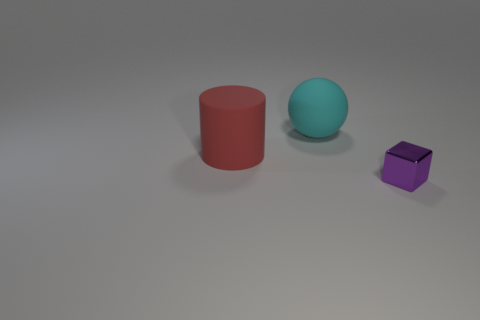Add 2 tiny purple blocks. How many objects exist? 5 Subtract 0 yellow cubes. How many objects are left? 3 Subtract all balls. How many objects are left? 2 Subtract all small things. Subtract all cyan balls. How many objects are left? 1 Add 3 large red rubber cylinders. How many large red rubber cylinders are left? 4 Add 3 tiny purple cubes. How many tiny purple cubes exist? 4 